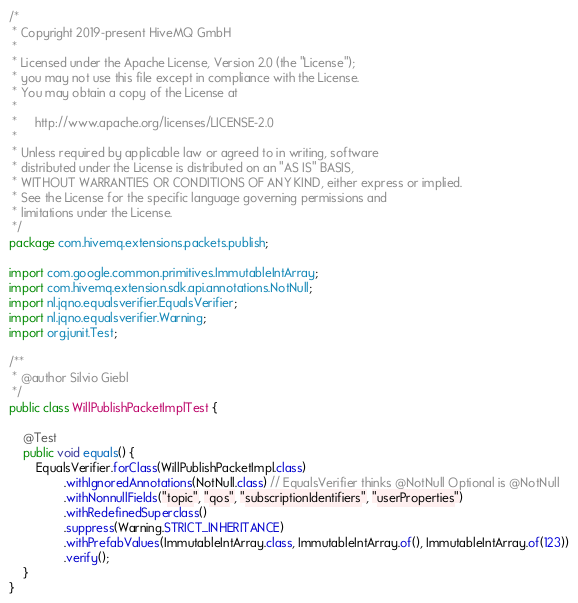<code> <loc_0><loc_0><loc_500><loc_500><_Java_>/*
 * Copyright 2019-present HiveMQ GmbH
 *
 * Licensed under the Apache License, Version 2.0 (the "License");
 * you may not use this file except in compliance with the License.
 * You may obtain a copy of the License at
 *
 *     http://www.apache.org/licenses/LICENSE-2.0
 *
 * Unless required by applicable law or agreed to in writing, software
 * distributed under the License is distributed on an "AS IS" BASIS,
 * WITHOUT WARRANTIES OR CONDITIONS OF ANY KIND, either express or implied.
 * See the License for the specific language governing permissions and
 * limitations under the License.
 */
package com.hivemq.extensions.packets.publish;

import com.google.common.primitives.ImmutableIntArray;
import com.hivemq.extension.sdk.api.annotations.NotNull;
import nl.jqno.equalsverifier.EqualsVerifier;
import nl.jqno.equalsverifier.Warning;
import org.junit.Test;

/**
 * @author Silvio Giebl
 */
public class WillPublishPacketImplTest {

    @Test
    public void equals() {
        EqualsVerifier.forClass(WillPublishPacketImpl.class)
                .withIgnoredAnnotations(NotNull.class) // EqualsVerifier thinks @NotNull Optional is @NotNull
                .withNonnullFields("topic", "qos", "subscriptionIdentifiers", "userProperties")
                .withRedefinedSuperclass()
                .suppress(Warning.STRICT_INHERITANCE)
                .withPrefabValues(ImmutableIntArray.class, ImmutableIntArray.of(), ImmutableIntArray.of(123))
                .verify();
    }
}</code> 